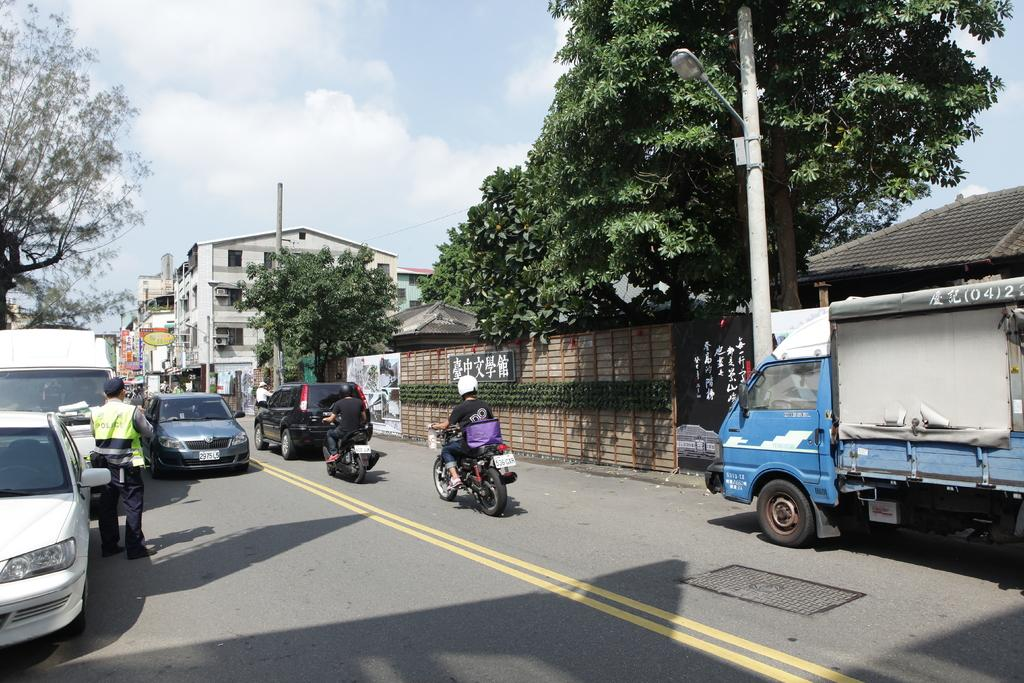What can be seen on the road in the image? There are vehicles on the road in the image. What is visible in the background of the image? There are buildings, boards, trees, poles, and wires in the background of the image. How is the sky depicted in the image? The sky is blue with clouds in the image. How many ladybugs are crawling on the vehicles in the image? There are no ladybugs present in the image; it only features vehicles on the road. What hobbies do the people in the buildings have? There is no information about the people in the buildings or their hobbies in the image. 